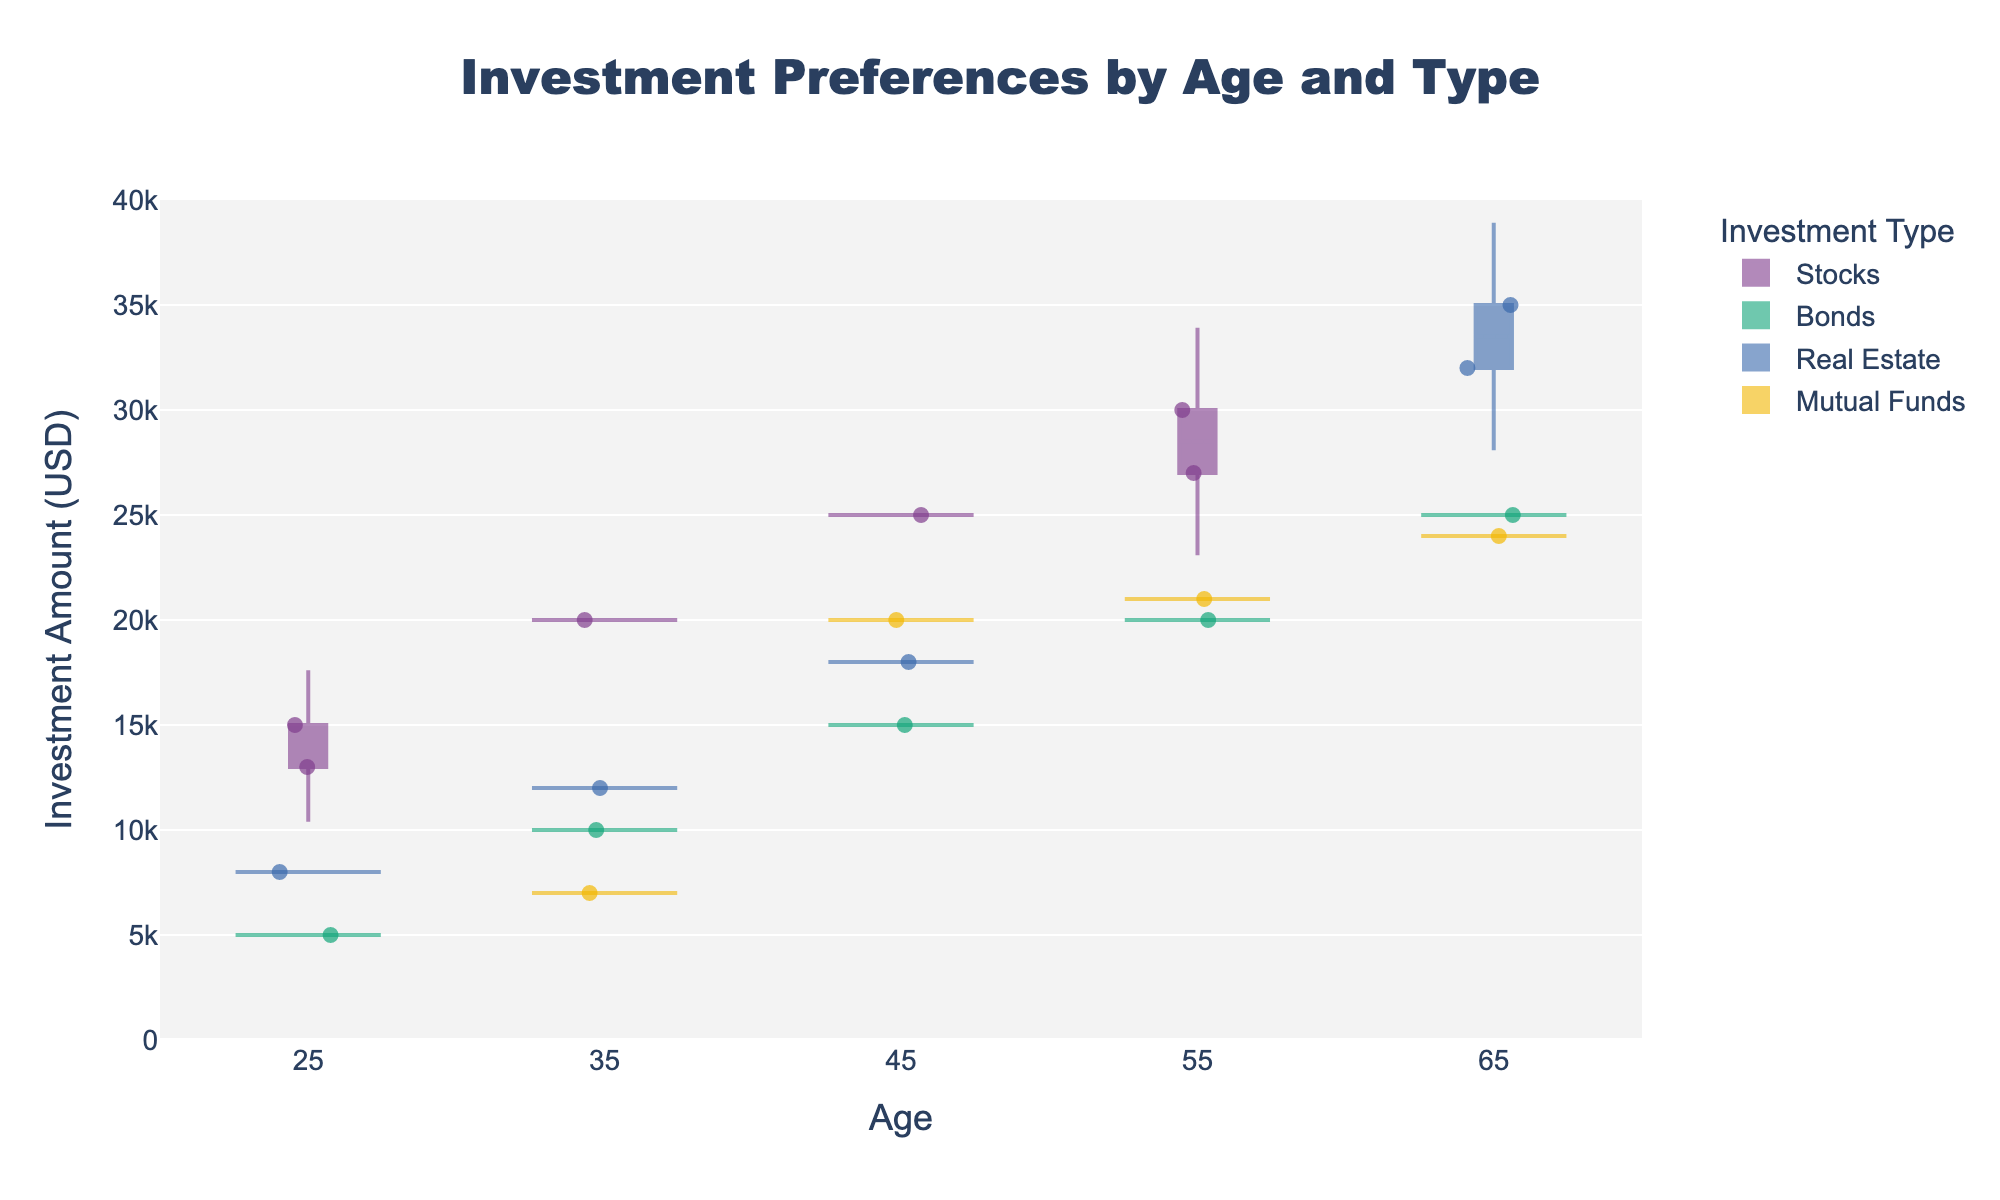How many different investment types are displayed in the figure? The figure shows different colored violins representing various investment types. Count the number of unique violin plots/colors.
Answer: 6 What is the title of the chart? Look at the title at the top of the figure. It should be clearly centered and prominent.
Answer: Investment Preferences by Age and Type Which age group has the highest investment amount in Real Estate? Identify the age range along the x-axis and find the Real Estate violin plot. Observe which age has the uppermost vertical stretch.
Answer: 65 What is the trend in the median investment amount in Stocks as age increases? Locate the Stock investment violins and observe the position of the horizontal line inside each violin plot. Track if the median line tends to rise or fall with age.
Answer: Increasing For Bonds, which age group shows the greatest range of investment amounts? Look for the Bonds violin plot, identify the vertical span within each age group, and compare their lengths.
Answer: 45 Which investment type seems most popular among clients aged 45 based on the density of points? Observe the concentration of jittered points within the 45 age group. The highest density indicates the most popular investment type.
Answer: Stocks What's the average investment amount in Mutual Funds across all age groups? Identify and follow the Mutual Funds violin plots for each age group, then visually estimate the average from the mean line or central tendency of each plot. Note: This step requires some estimation, but recognizing and averaging their medians or means is the key.
Answer: 20500 How does gender impact investment in Stocks across different ages? Note the distribution of points along each age group and separate them by gender. Compare if there are more men's or women's points and the amounts invested.
Answer: Variably; more males invest, except at age 55 where it's balanced In what investment type do we see an unusual outlier, if any? Examine each violin plot and locate points that stand significantly apart from the main data distribution. Identify the investment type of that plot.
Answer: Stocks at age 55 What is the smallest investment amount recorded in any investment type? Look for the lowest point in the jittered data points across all violin plots. Check if any are particularly lower than the rest.
Answer: 5000 